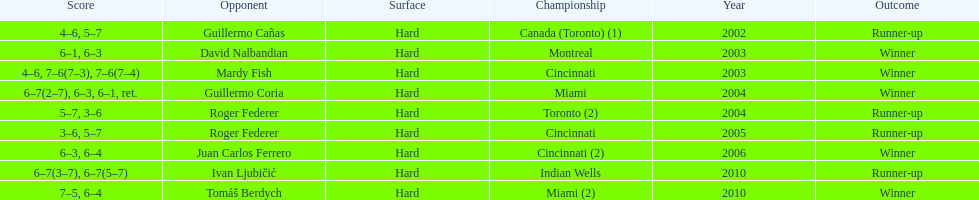What is his highest number of consecutive wins? 3. 